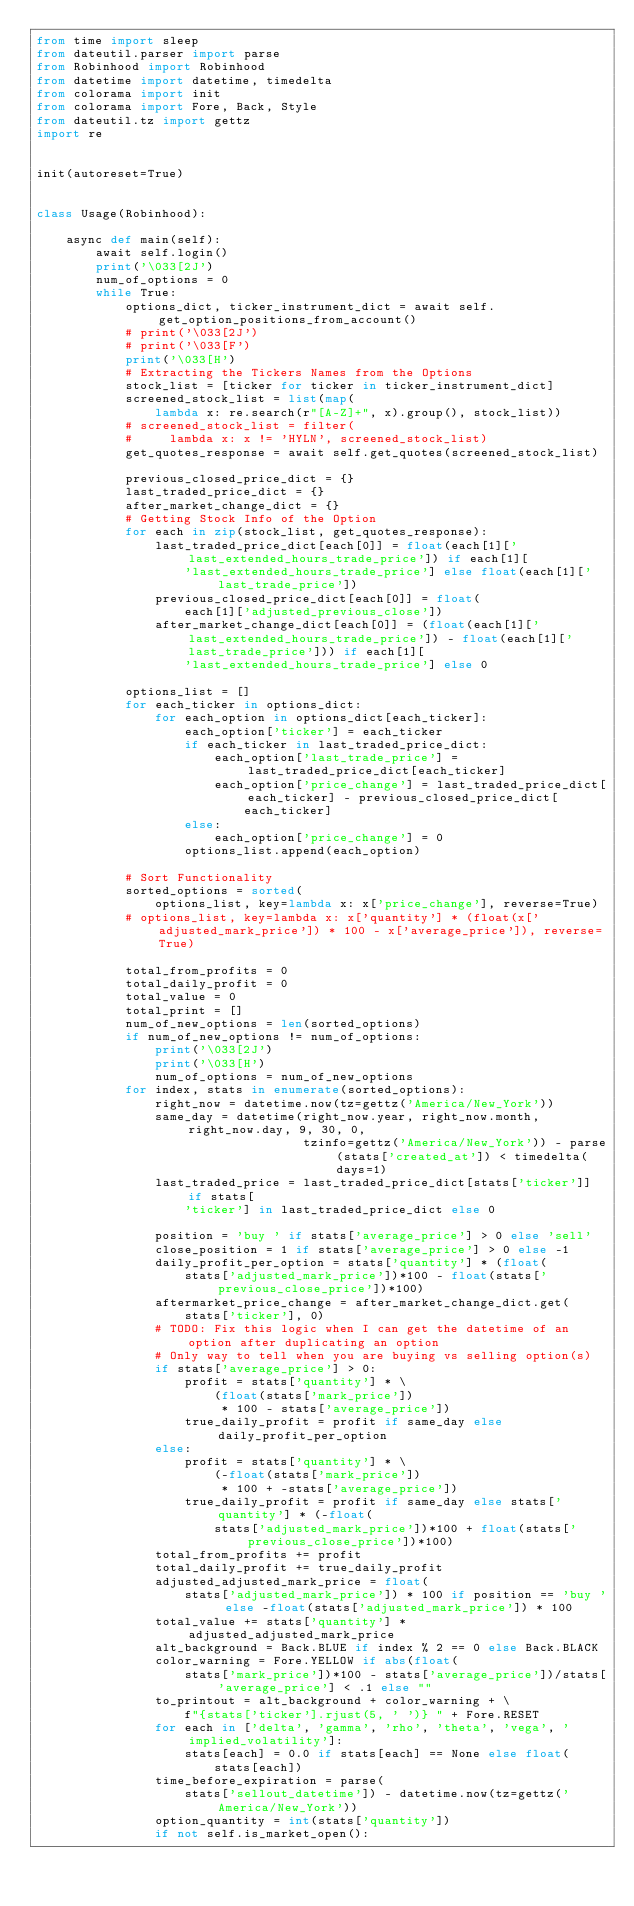Convert code to text. <code><loc_0><loc_0><loc_500><loc_500><_Python_>from time import sleep
from dateutil.parser import parse
from Robinhood import Robinhood
from datetime import datetime, timedelta
from colorama import init
from colorama import Fore, Back, Style
from dateutil.tz import gettz
import re


init(autoreset=True)


class Usage(Robinhood):

    async def main(self):
        await self.login()
        print('\033[2J')
        num_of_options = 0
        while True:
            options_dict, ticker_instrument_dict = await self.get_option_positions_from_account()
            # print('\033[2J')
            # print('\033[F')
            print('\033[H')
            # Extracting the Tickers Names from the Options
            stock_list = [ticker for ticker in ticker_instrument_dict]
            screened_stock_list = list(map(
                lambda x: re.search(r"[A-Z]+", x).group(), stock_list))
            # screened_stock_list = filter(
            #     lambda x: x != 'HYLN', screened_stock_list)
            get_quotes_response = await self.get_quotes(screened_stock_list)

            previous_closed_price_dict = {}
            last_traded_price_dict = {}
            after_market_change_dict = {}
            # Getting Stock Info of the Option
            for each in zip(stock_list, get_quotes_response):
                last_traded_price_dict[each[0]] = float(each[1]['last_extended_hours_trade_price']) if each[1][
                    'last_extended_hours_trade_price'] else float(each[1]['last_trade_price'])
                previous_closed_price_dict[each[0]] = float(
                    each[1]['adjusted_previous_close'])
                after_market_change_dict[each[0]] = (float(each[1]['last_extended_hours_trade_price']) - float(each[1]['last_trade_price'])) if each[1][
                    'last_extended_hours_trade_price'] else 0

            options_list = []
            for each_ticker in options_dict:
                for each_option in options_dict[each_ticker]:
                    each_option['ticker'] = each_ticker
                    if each_ticker in last_traded_price_dict:
                        each_option['last_trade_price'] = last_traded_price_dict[each_ticker]
                        each_option['price_change'] = last_traded_price_dict[each_ticker] - previous_closed_price_dict[
                            each_ticker]
                    else:
                        each_option['price_change'] = 0
                    options_list.append(each_option)

            # Sort Functionality
            sorted_options = sorted(
                options_list, key=lambda x: x['price_change'], reverse=True)
            # options_list, key=lambda x: x['quantity'] * (float(x['adjusted_mark_price']) * 100 - x['average_price']), reverse=True)

            total_from_profits = 0
            total_daily_profit = 0
            total_value = 0
            total_print = []
            num_of_new_options = len(sorted_options)
            if num_of_new_options != num_of_options:
                print('\033[2J')
                print('\033[H')
                num_of_options = num_of_new_options
            for index, stats in enumerate(sorted_options):
                right_now = datetime.now(tz=gettz('America/New_York'))
                same_day = datetime(right_now.year, right_now.month, right_now.day, 9, 30, 0,
                                    tzinfo=gettz('America/New_York')) - parse(stats['created_at']) < timedelta(days=1)
                last_traded_price = last_traded_price_dict[stats['ticker']] if stats[
                    'ticker'] in last_traded_price_dict else 0

                position = 'buy ' if stats['average_price'] > 0 else 'sell'
                close_position = 1 if stats['average_price'] > 0 else -1
                daily_profit_per_option = stats['quantity'] * (float(
                    stats['adjusted_mark_price'])*100 - float(stats['previous_close_price'])*100)
                aftermarket_price_change = after_market_change_dict.get(
                    stats['ticker'], 0)
                # TODO: Fix this logic when I can get the datetime of an option after duplicating an option
                # Only way to tell when you are buying vs selling option(s)
                if stats['average_price'] > 0:
                    profit = stats['quantity'] * \
                        (float(stats['mark_price'])
                         * 100 - stats['average_price'])
                    true_daily_profit = profit if same_day else daily_profit_per_option
                else:
                    profit = stats['quantity'] * \
                        (-float(stats['mark_price'])
                         * 100 + -stats['average_price'])
                    true_daily_profit = profit if same_day else stats['quantity'] * (-float(
                        stats['adjusted_mark_price'])*100 + float(stats['previous_close_price'])*100)
                total_from_profits += profit
                total_daily_profit += true_daily_profit
                adjusted_adjusted_mark_price = float(
                    stats['adjusted_mark_price']) * 100 if position == 'buy ' else -float(stats['adjusted_mark_price']) * 100
                total_value += stats['quantity'] * adjusted_adjusted_mark_price
                alt_background = Back.BLUE if index % 2 == 0 else Back.BLACK
                color_warning = Fore.YELLOW if abs(float(
                    stats['mark_price'])*100 - stats['average_price'])/stats['average_price'] < .1 else ""
                to_printout = alt_background + color_warning + \
                    f"{stats['ticker'].rjust(5, ' ')} " + Fore.RESET
                for each in ['delta', 'gamma', 'rho', 'theta', 'vega', 'implied_volatility']:
                    stats[each] = 0.0 if stats[each] == None else float(
                        stats[each])
                time_before_expiration = parse(
                    stats['sellout_datetime']) - datetime.now(tz=gettz('America/New_York'))
                option_quantity = int(stats['quantity'])
                if not self.is_market_open():</code> 